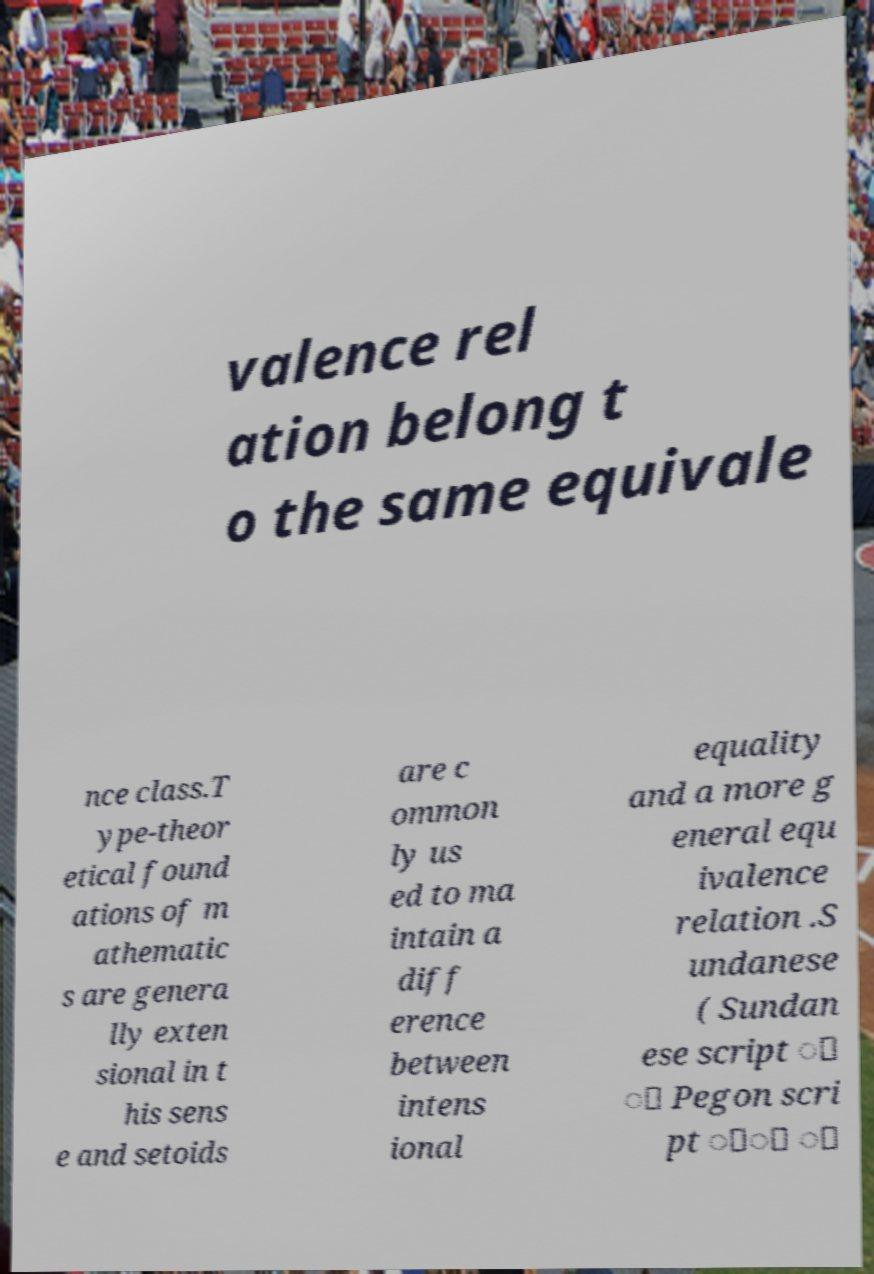Can you accurately transcribe the text from the provided image for me? valence rel ation belong t o the same equivale nce class.T ype-theor etical found ations of m athematic s are genera lly exten sional in t his sens e and setoids are c ommon ly us ed to ma intain a diff erence between intens ional equality and a more g eneral equ ivalence relation .S undanese ( Sundan ese script ᮥ ᮪ Pegon scri pt ََ ُ 